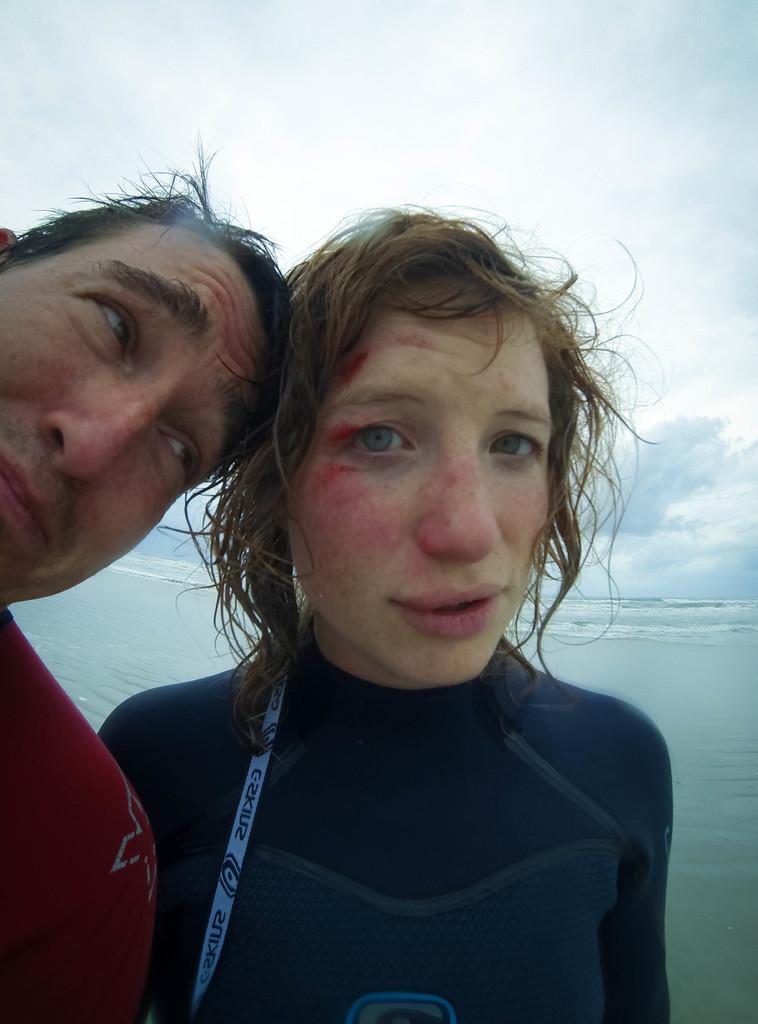How would you summarize this image in a sentence or two? In this image in the front there are persons. In the background there is an ocean and the sky is cloudy. 